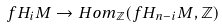Convert formula to latex. <formula><loc_0><loc_0><loc_500><loc_500>f H _ { i } M \to H o m _ { \mathbb { Z } } ( f H _ { n - i } M , \mathbb { Z } )</formula> 